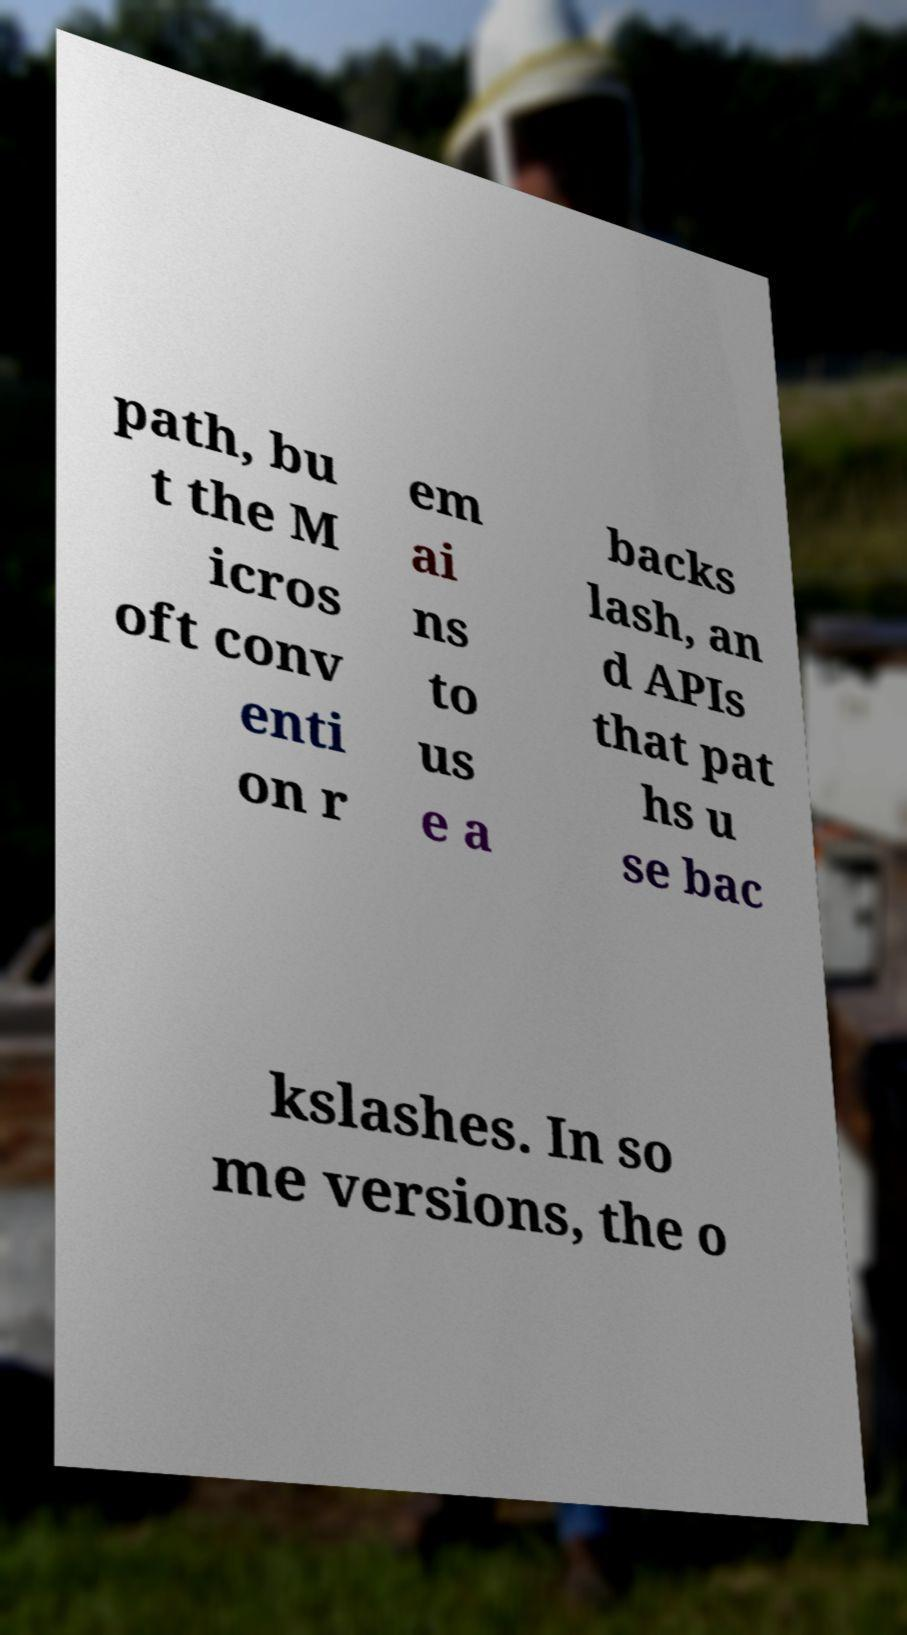For documentation purposes, I need the text within this image transcribed. Could you provide that? path, bu t the M icros oft conv enti on r em ai ns to us e a backs lash, an d APIs that pat hs u se bac kslashes. In so me versions, the o 